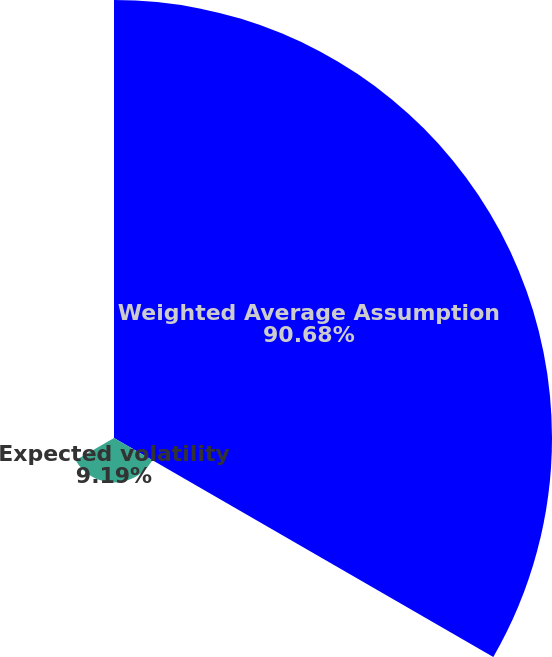Convert chart. <chart><loc_0><loc_0><loc_500><loc_500><pie_chart><fcel>Weighted Average Assumption<fcel>Expected volatility<fcel>Risk-free interest rate<nl><fcel>90.68%<fcel>9.19%<fcel>0.13%<nl></chart> 